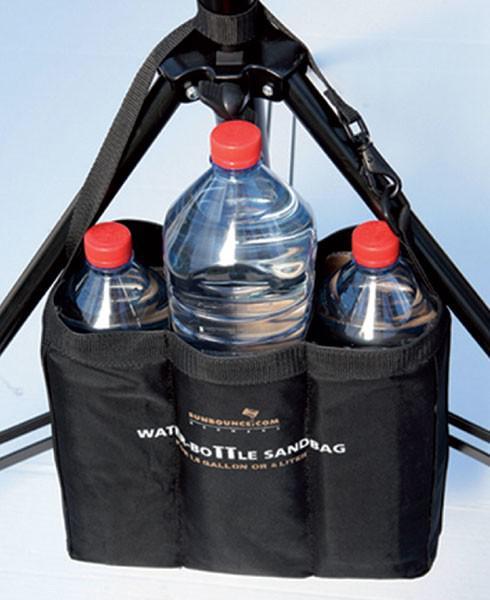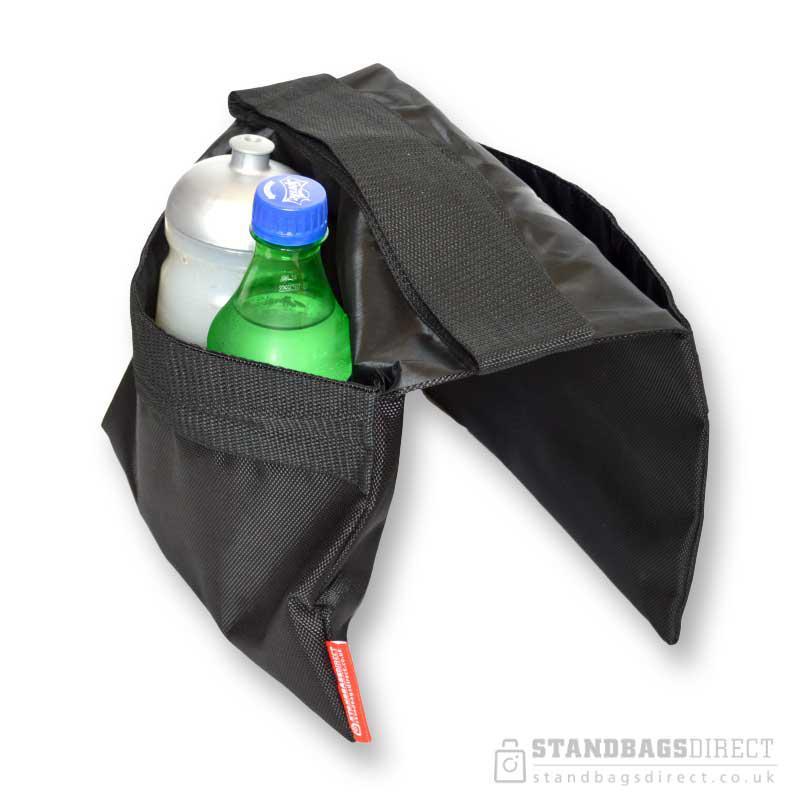The first image is the image on the left, the second image is the image on the right. Considering the images on both sides, is "in the image on the left, there is at least 3 containers visible." valid? Answer yes or no. Yes. 